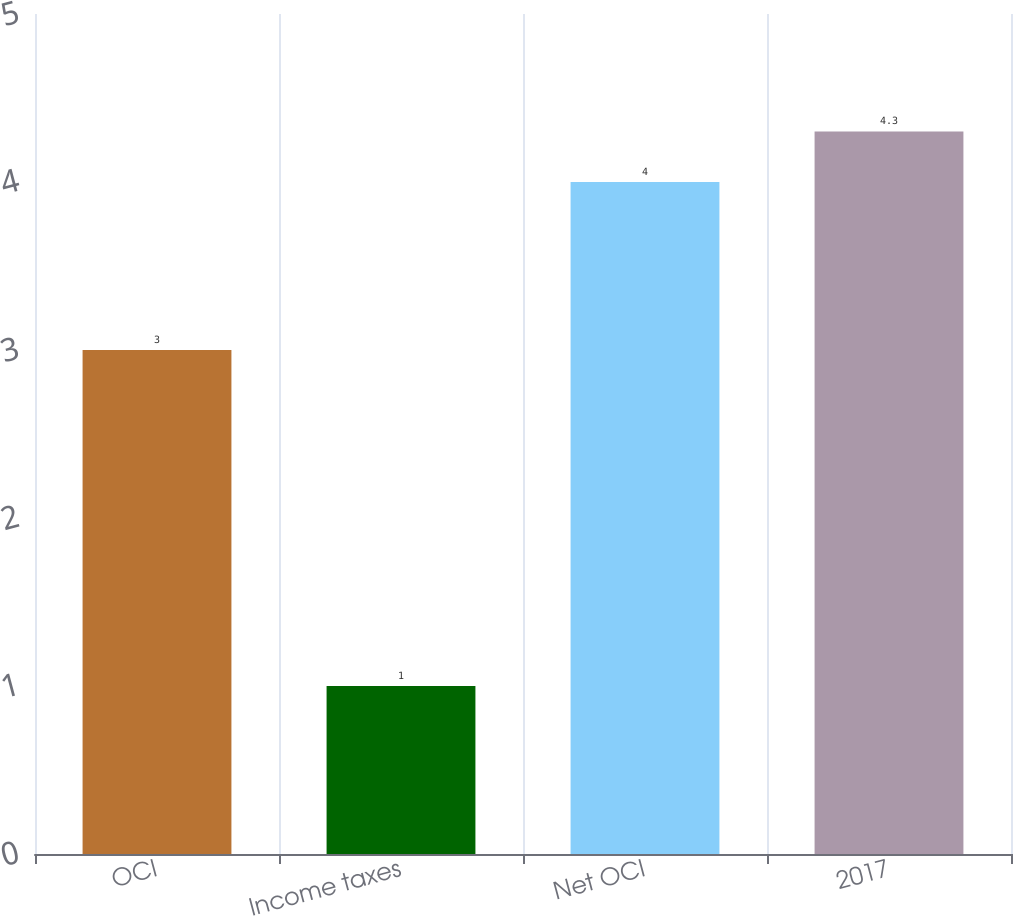Convert chart to OTSL. <chart><loc_0><loc_0><loc_500><loc_500><bar_chart><fcel>OCI<fcel>Income taxes<fcel>Net OCI<fcel>2017<nl><fcel>3<fcel>1<fcel>4<fcel>4.3<nl></chart> 